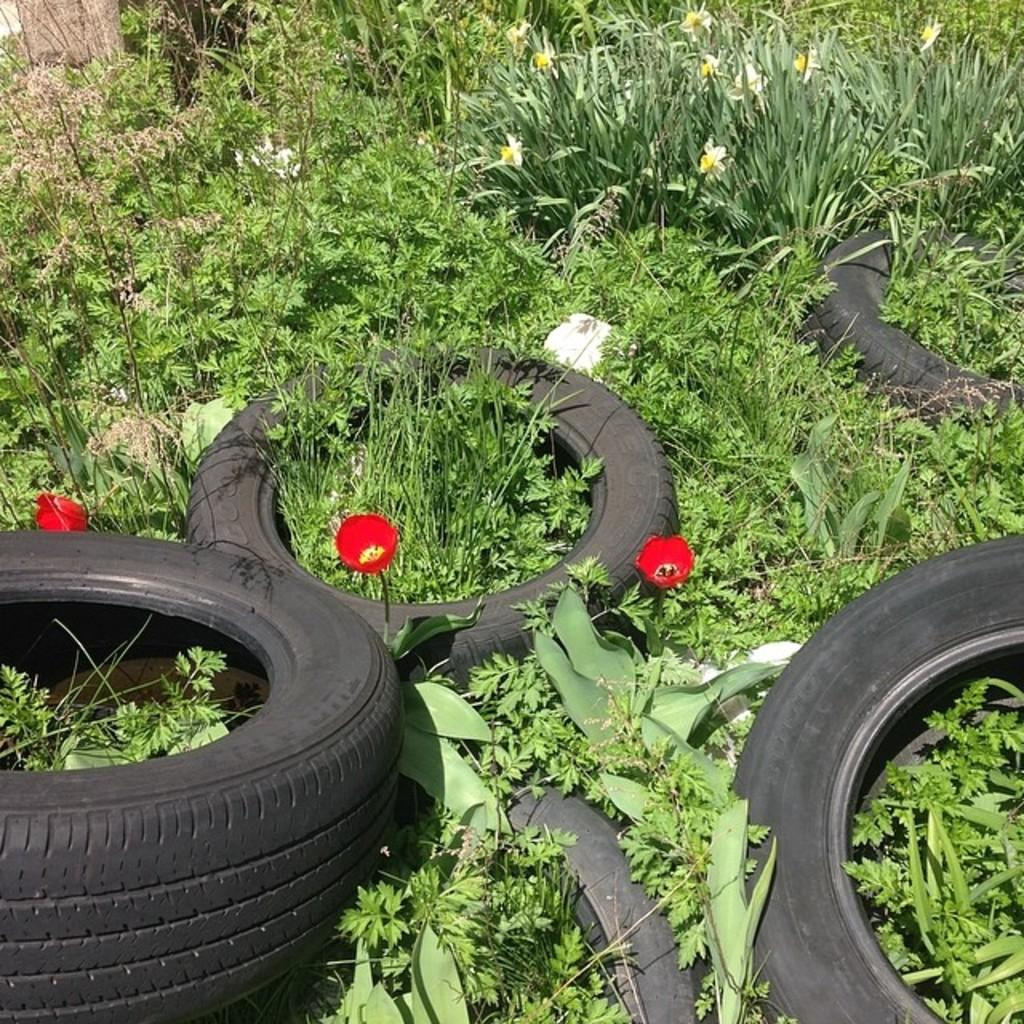What types of living organisms can be seen in the image? Plants and flowers are visible in the image. Can you describe the objects at the bottom of the image? There are tyres at the bottom of the image. What type of songs can be heard coming from the plants in the image? There are no songs present in the image, as plants do not produce or play music. 